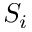<formula> <loc_0><loc_0><loc_500><loc_500>S _ { i }</formula> 